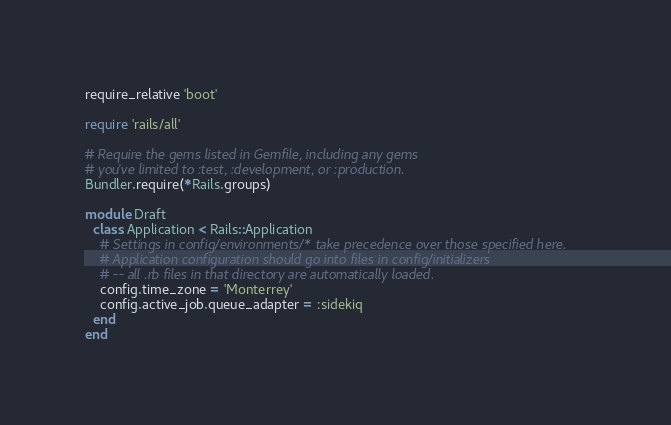<code> <loc_0><loc_0><loc_500><loc_500><_Ruby_>require_relative 'boot'

require 'rails/all'

# Require the gems listed in Gemfile, including any gems
# you've limited to :test, :development, or :production.
Bundler.require(*Rails.groups)

module Draft
  class Application < Rails::Application
    # Settings in config/environments/* take precedence over those specified here.
    # Application configuration should go into files in config/initializers
    # -- all .rb files in that directory are automatically loaded.
    config.time_zone = 'Monterrey'
    config.active_job.queue_adapter = :sidekiq
  end
end
</code> 